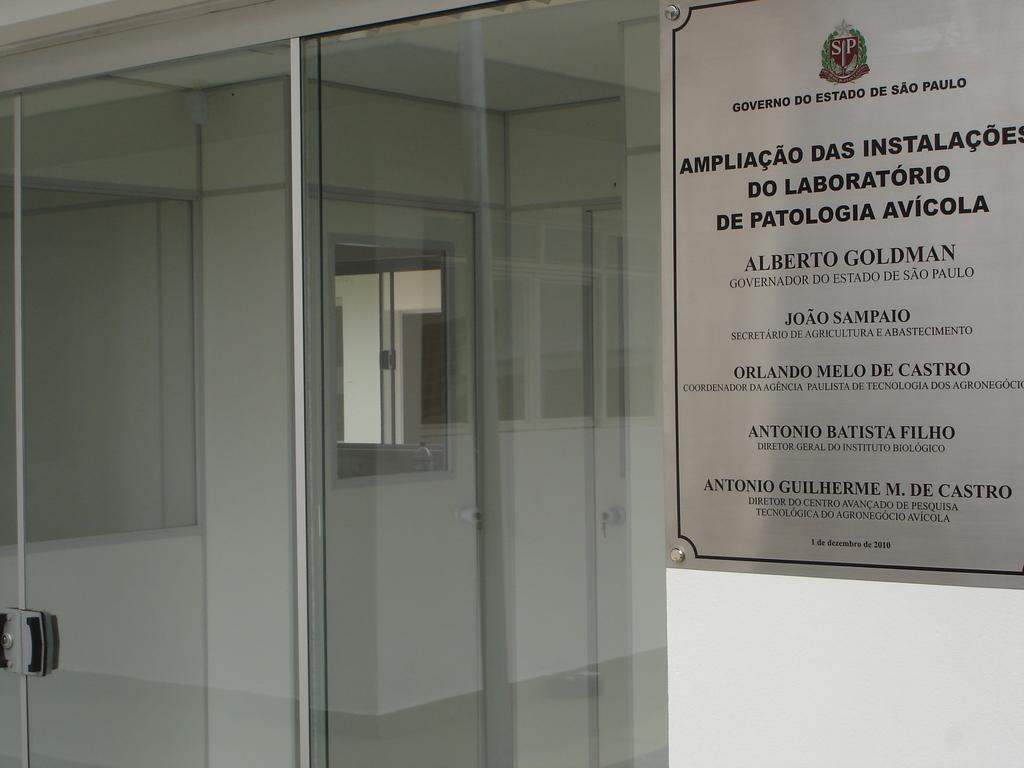<image>
Write a terse but informative summary of the picture. A glass door with a sign in foreign words with the year 2010 at the bottom. 